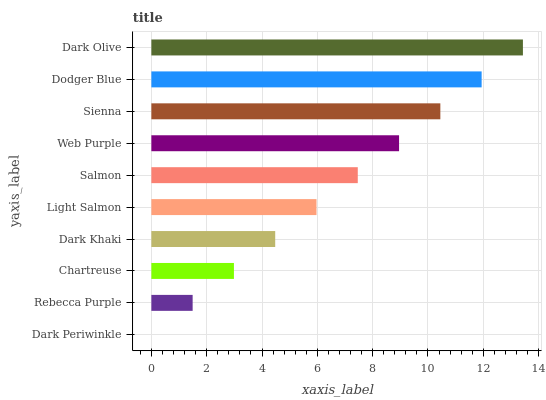Is Dark Periwinkle the minimum?
Answer yes or no. Yes. Is Dark Olive the maximum?
Answer yes or no. Yes. Is Rebecca Purple the minimum?
Answer yes or no. No. Is Rebecca Purple the maximum?
Answer yes or no. No. Is Rebecca Purple greater than Dark Periwinkle?
Answer yes or no. Yes. Is Dark Periwinkle less than Rebecca Purple?
Answer yes or no. Yes. Is Dark Periwinkle greater than Rebecca Purple?
Answer yes or no. No. Is Rebecca Purple less than Dark Periwinkle?
Answer yes or no. No. Is Salmon the high median?
Answer yes or no. Yes. Is Light Salmon the low median?
Answer yes or no. Yes. Is Web Purple the high median?
Answer yes or no. No. Is Dark Periwinkle the low median?
Answer yes or no. No. 